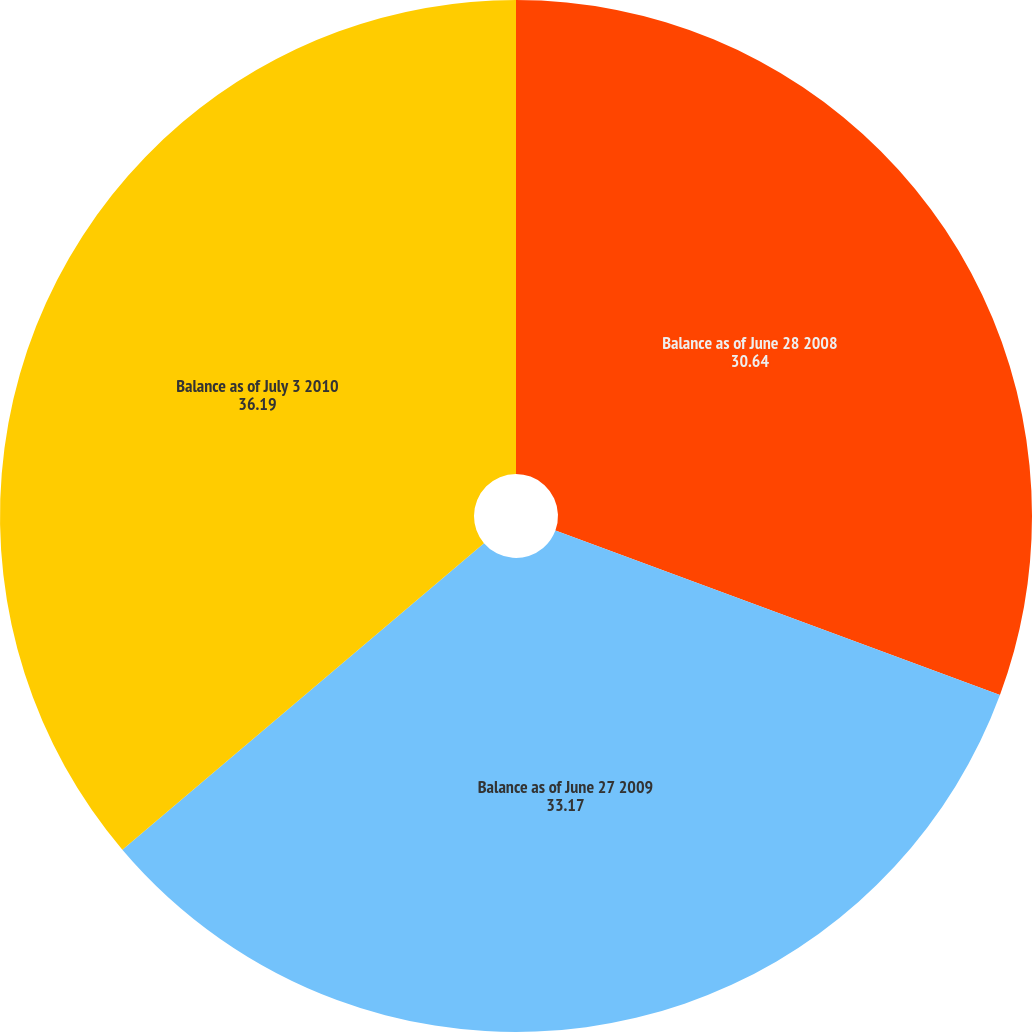<chart> <loc_0><loc_0><loc_500><loc_500><pie_chart><fcel>Balance as of June 28 2008<fcel>Balance as of June 27 2009<fcel>Balance as of July 3 2010<nl><fcel>30.64%<fcel>33.17%<fcel>36.19%<nl></chart> 